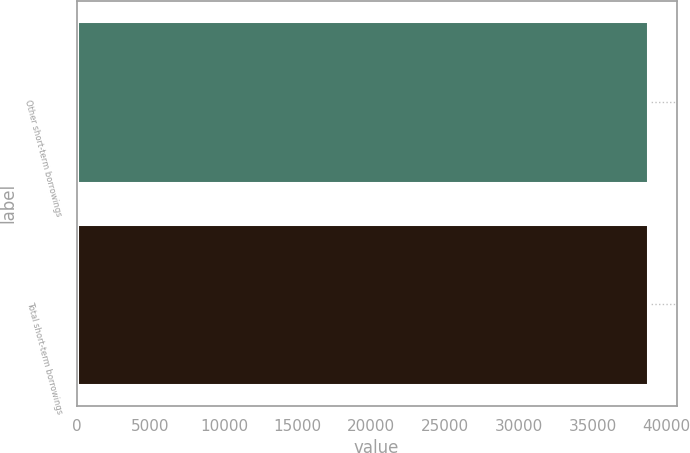<chart> <loc_0><loc_0><loc_500><loc_500><bar_chart><fcel>Other short-term borrowings<fcel>Total short-term borrowings<nl><fcel>38755<fcel>38755.1<nl></chart> 